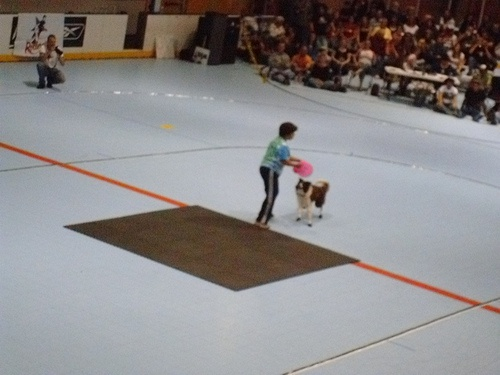Describe the objects in this image and their specific colors. I can see people in maroon, black, and gray tones, people in maroon, black, gray, and darkgray tones, people in maroon, black, and gray tones, dog in maroon, darkgray, black, and gray tones, and people in maroon, black, and gray tones in this image. 